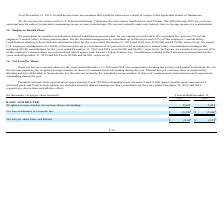According to Neonode's financial document, How did the company compute the basic net loss per common share for 2018 and 2019? by dividing the net loss attributable to Neonode Inc. for the relevant period by the weighted average number of shares of common stock outstanding during the year. The document states: "ars ended December 31, 2019 and 2018 was computed by dividing the net loss attributable to Neonode Inc. for the relevant period by the weighted averag..." Also, How do we compute diluted loss per common share? by dividing net loss attributable to Neonode Inc. for the relevant period by the weighted average number of shares of common stock and common stock equivalents outstanding during the year. The document states: "e year. Diluted loss per common share is computed by dividing net loss attributable to Neonode Inc. for the relevant period by the weighted average nu..." Also, What was the net loss attributable to Neonode Inc. in 2018 and 2019? The document shows two values: $(5,298) and $(3,060) (in thousands). Also, can you calculate: What is the percentage change in the weighted average number of common shares outstanding from 2018 to 2019? To answer this question, I need to perform calculations using the financial data. The calculation is: (8,844 - 5,884)/5,884 , which equals 50.31 (percentage). This is based on the information: "ghted average number of common shares outstanding 8,844 5,884 average number of common shares outstanding 8,844 5,884..." The key data points involved are: 5,884, 8,844. Additionally, Which year has the highest net loss per share basic and diluted? According to the financial document, 2019. The relevant text states: "ntribution plans for the years ended December 31, 2019 and 2018 were $395,000 and $413,000, respectively. We match U.S. employee contributions to a 401(K)..." Also, can you calculate: What is the ratio of net loss attributable to Neonode Inc. in 2018 compared to 2019? Based on the calculation: 3,060/5,298 , the result is 0.58. This is based on the information: "Net loss attributable to Neonode Inc. $ (5,298 ) $ (3,060 ) t loss attributable to Neonode Inc. $ (5,298 ) $ (3,060 )..." The key data points involved are: 3,060, 5,298. 